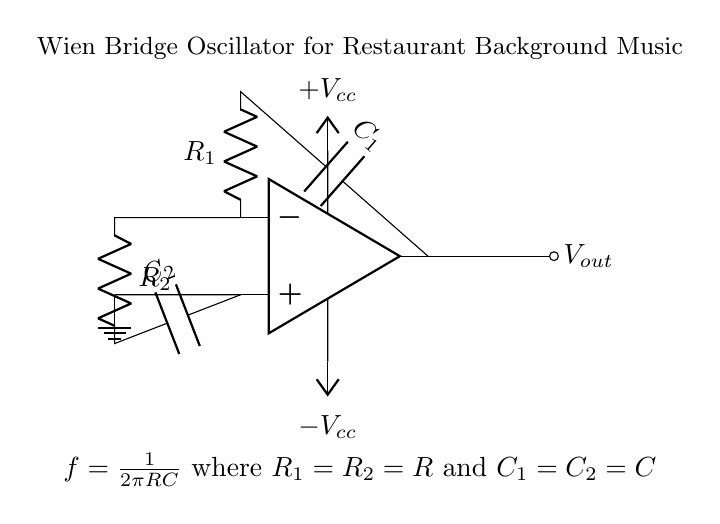What type of amplifier is used in this circuit? The circuit features an operational amplifier, commonly referred to as an op-amp, which is essential for the functionality of the Wien bridge oscillator.
Answer: Operational amplifier What is the role of the capacitors in this circuit? Capacitors C1 and C2 are part of the feedback network, determining the frequency of oscillation by storing and releasing energy, which shapes the output signal.
Answer: Frequency determination What is the purpose of the resistors in this oscillator? Resistors R1 and R2 set the gain of the op-amp and, along with the capacitors, influence the frequency of oscillation, creating the desired output waveform.
Answer: Gain and frequency setting What is the output voltage name shown in the diagram? The output voltage of the Wien bridge oscillator is labeled as Vout in the diagram, representing the signal generated for audio output in the restaurant.
Answer: Vout What is the formula for frequency in this oscillator? The frequency of the Wien bridge oscillator is determined by the formula f = 1 / (2πRC), where R and C are the resistor and capacitor values, respectively, which control the oscillation rate.
Answer: f = 1 / (2πRC) What connects the negative input of the op-amp to the circuit? The negative input of the op-amp is connected through a resistor R2 and then to a capacitor C2 in the feedback network, ensuring stability and proper oscillation.
Answer: Resistor R2 and Capacitor C2 What powers the operational amplifier in this circuit? The operational amplifier is powered by a dual supply voltage, labeled as +Vcc and -Vcc in the diagram, essential for the op-amp to function correctly.
Answer: Dual supply voltage 